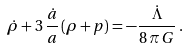Convert formula to latex. <formula><loc_0><loc_0><loc_500><loc_500>\dot { \rho } + 3 \, \frac { \dot { a } } { a } \, ( \rho + p ) = - \frac { \dot { \Lambda } } { 8 \, \pi \, G } \, .</formula> 